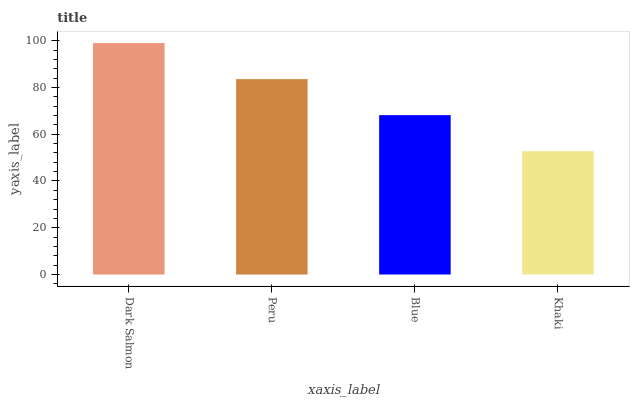Is Khaki the minimum?
Answer yes or no. Yes. Is Dark Salmon the maximum?
Answer yes or no. Yes. Is Peru the minimum?
Answer yes or no. No. Is Peru the maximum?
Answer yes or no. No. Is Dark Salmon greater than Peru?
Answer yes or no. Yes. Is Peru less than Dark Salmon?
Answer yes or no. Yes. Is Peru greater than Dark Salmon?
Answer yes or no. No. Is Dark Salmon less than Peru?
Answer yes or no. No. Is Peru the high median?
Answer yes or no. Yes. Is Blue the low median?
Answer yes or no. Yes. Is Blue the high median?
Answer yes or no. No. Is Dark Salmon the low median?
Answer yes or no. No. 